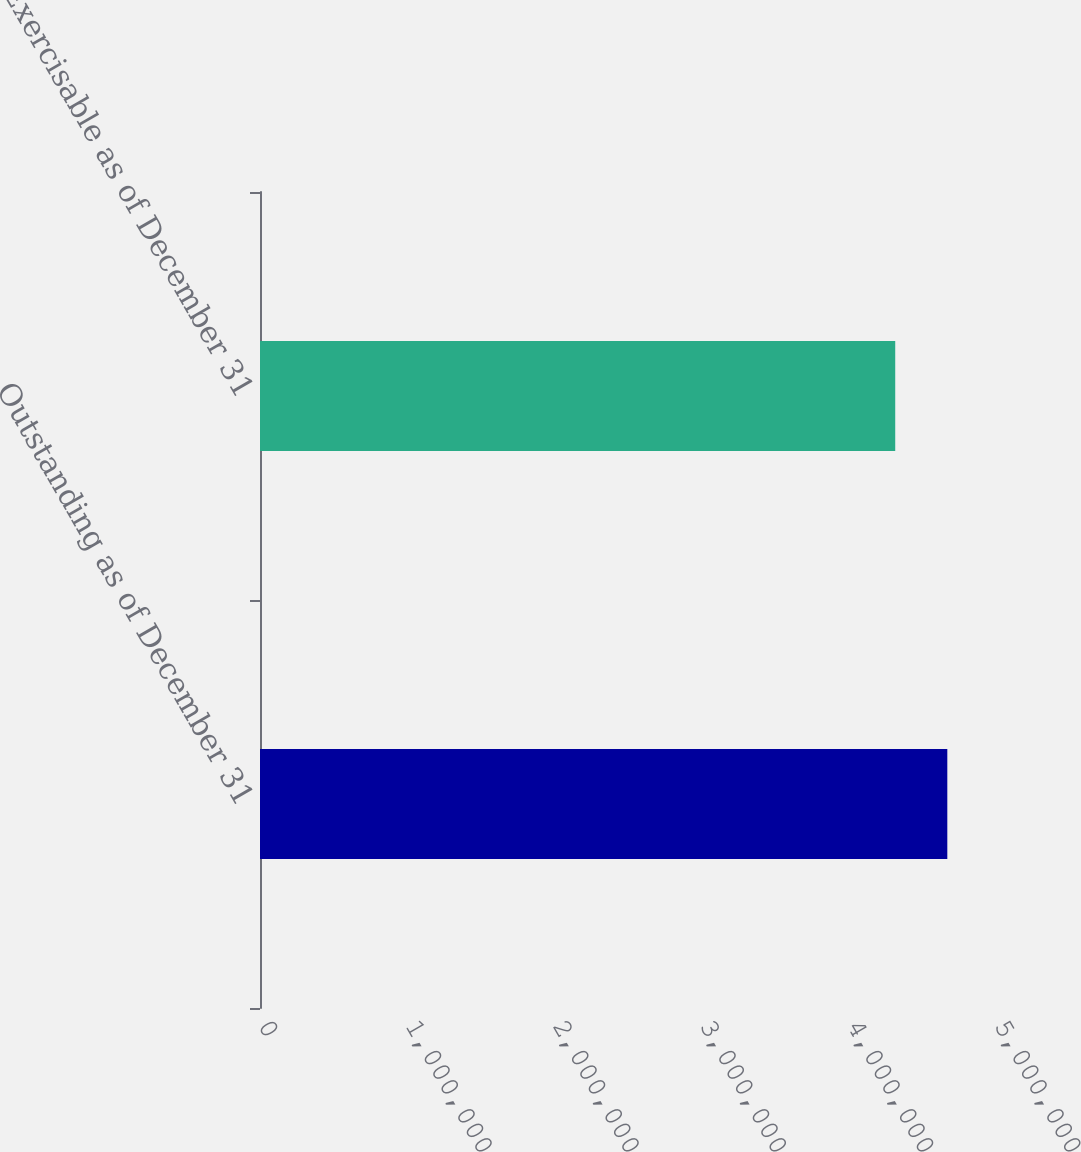<chart> <loc_0><loc_0><loc_500><loc_500><bar_chart><fcel>Outstanding as of December 31<fcel>Exercisable as of December 31<nl><fcel>4.66922e+06<fcel>4.31541e+06<nl></chart> 